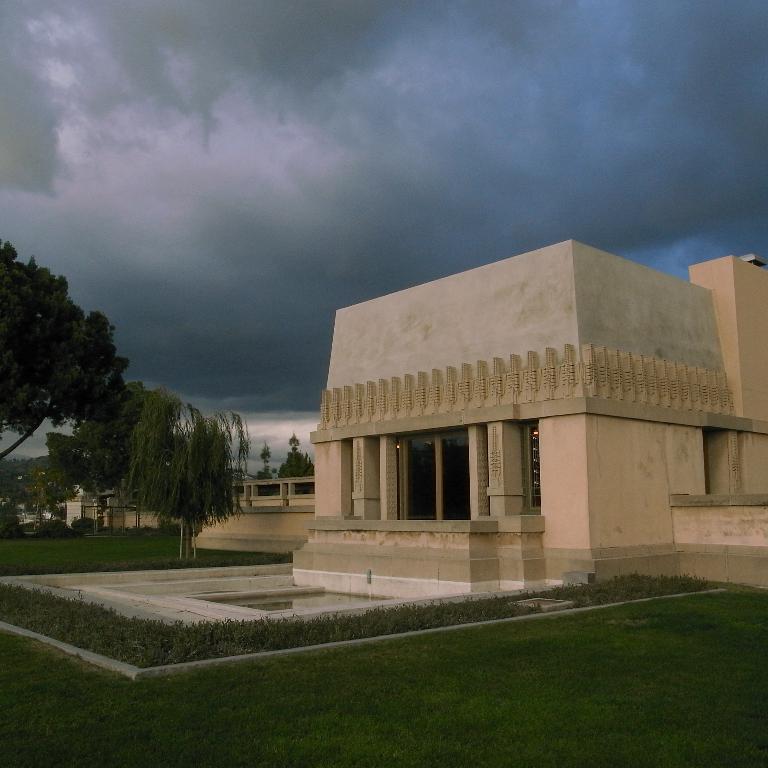In one or two sentences, can you explain what this image depicts? In this picture we can see few buildings and trees, in the background we can find clouds. 